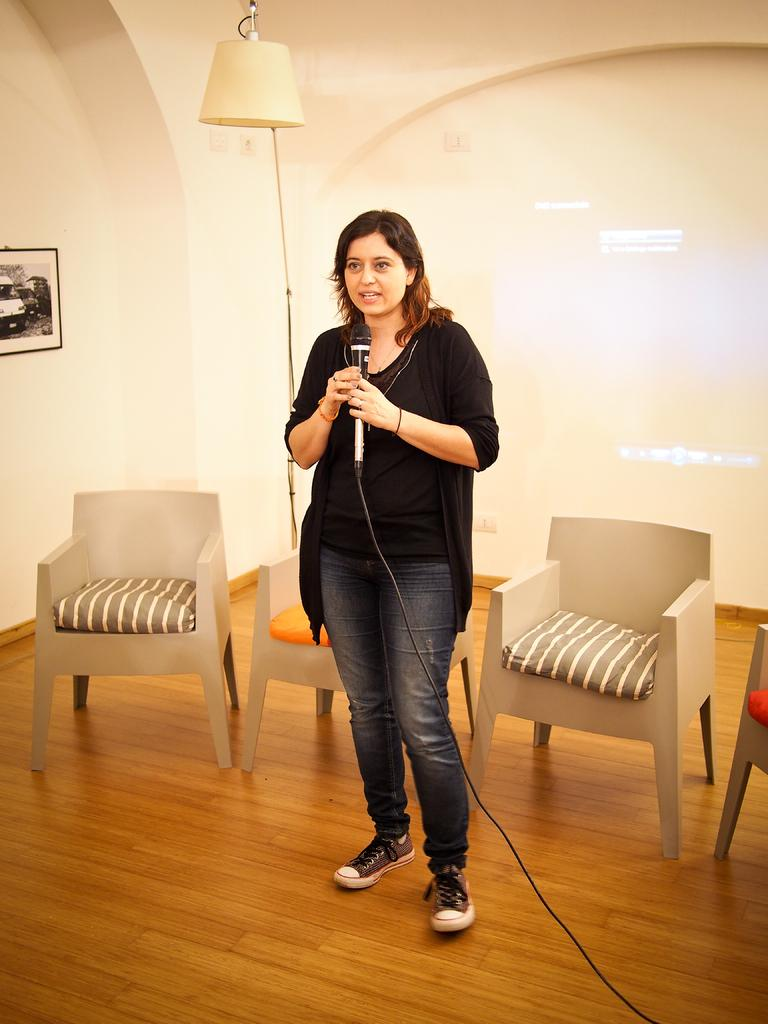What is the woman in the image holding? The woman is holding a microphone. What can be seen in the background of the image? There are chairs, a lamp, a wall, and a photo frame attached to the wall in the background of the image. What might the woman be doing with the microphone? The woman might be using the microphone for speaking or singing. What type of poison is being administered to the animals in the zoo in the image? There is no zoo or animals present in the image, and therefore no poison can be observed. 